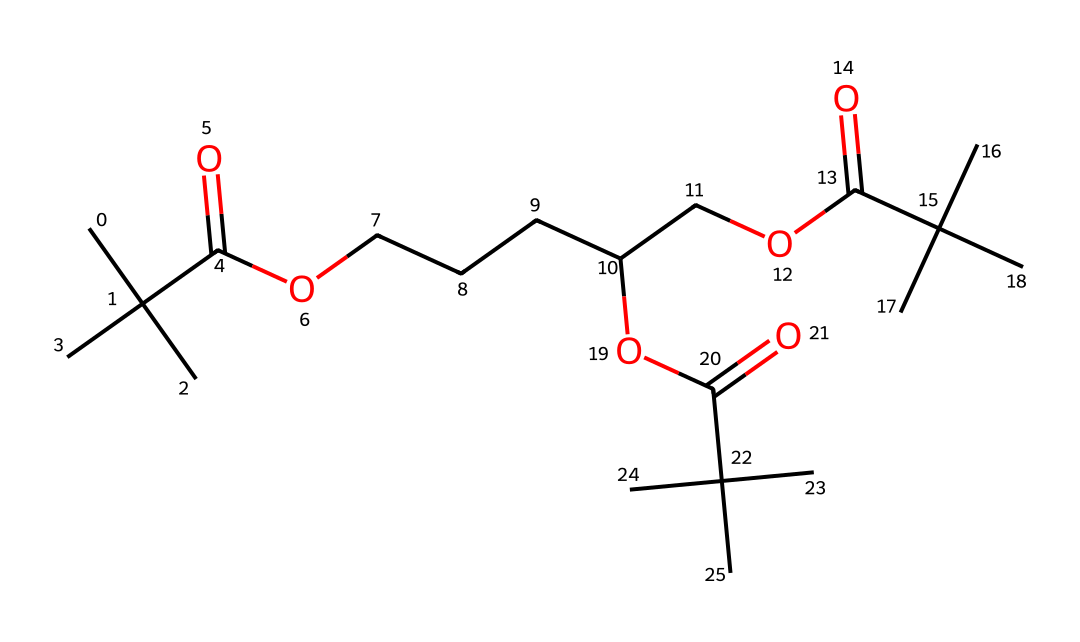What is the main functional group present in this molecule? The structure contains a carboxylic acid functional group indicated by the -COOH presence (the carbonyl and hydroxyl bonded to the same carbon) which is repeated in the molecule.
Answer: carboxylic acid How many ester functional groups are in this chemical? By analyzing the structure, there are ester (-COO-) groups present as they connect carbon chains and are derived from the reaction of an alcohol and a carboxylic acid; counting gives us three esters.
Answer: three What is the longest carbon chain in the molecule? The longest continuous chain can be traced by recognizing the connected carbon atoms. In this case, a straight chain of seven carbon atoms is identified within the structure.
Answer: seven What effect does the presence of multiple branched groups have on the properties of this polymer? The branching in this structure increases the spacing between polymer chains, potentially influencing the density and flexibility of the material, which is significant for film properties.
Answer: increases flexibility Determine the total number of carbon atoms in the molecule. The structure can be analyzed to count the distinct carbon atoms represented. In this molecule, there is a total of 22 carbon atoms present.
Answer: 22 Identify a likely application of this polymer in film technology. Given the presence of ester groups and the general structure, it suggests that this polymer can be used in making flexible film stock that requires durability and resistance to environmental factors.
Answer: flexible film stock Is this molecule likely to be soluble in water? The presence of multiple hydrophobic branches along with carboxylic acid impacts its water solubility. The hydrophobic parts outweigh the polar functional groups, making it less likely to be water-soluble.
Answer: less likely 